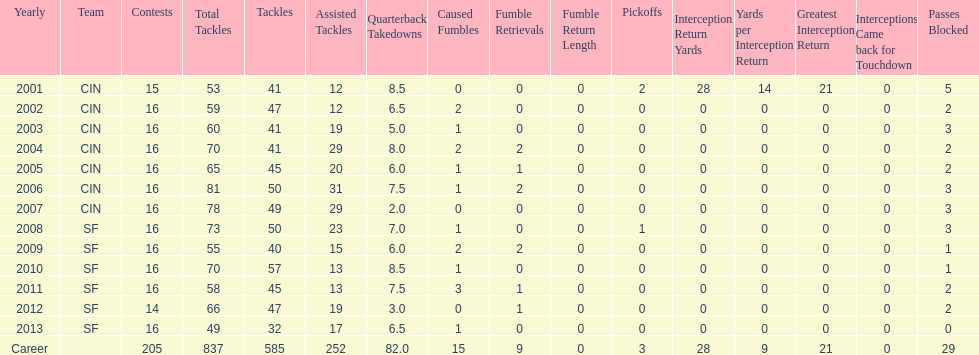How many seasons had combined tackles of 70 or more? 5. Write the full table. {'header': ['Yearly', 'Team', 'Contests', 'Total Tackles', 'Tackles', 'Assisted Tackles', 'Quarterback Takedowns', 'Caused Fumbles', 'Fumble Retrievals', 'Fumble Return Length', 'Pickoffs', 'Interception Return Yards', 'Yards per Interception Return', 'Greatest Interception Return', 'Interceptions Came back for Touchdown', 'Passes Blocked'], 'rows': [['2001', 'CIN', '15', '53', '41', '12', '8.5', '0', '0', '0', '2', '28', '14', '21', '0', '5'], ['2002', 'CIN', '16', '59', '47', '12', '6.5', '2', '0', '0', '0', '0', '0', '0', '0', '2'], ['2003', 'CIN', '16', '60', '41', '19', '5.0', '1', '0', '0', '0', '0', '0', '0', '0', '3'], ['2004', 'CIN', '16', '70', '41', '29', '8.0', '2', '2', '0', '0', '0', '0', '0', '0', '2'], ['2005', 'CIN', '16', '65', '45', '20', '6.0', '1', '1', '0', '0', '0', '0', '0', '0', '2'], ['2006', 'CIN', '16', '81', '50', '31', '7.5', '1', '2', '0', '0', '0', '0', '0', '0', '3'], ['2007', 'CIN', '16', '78', '49', '29', '2.0', '0', '0', '0', '0', '0', '0', '0', '0', '3'], ['2008', 'SF', '16', '73', '50', '23', '7.0', '1', '0', '0', '1', '0', '0', '0', '0', '3'], ['2009', 'SF', '16', '55', '40', '15', '6.0', '2', '2', '0', '0', '0', '0', '0', '0', '1'], ['2010', 'SF', '16', '70', '57', '13', '8.5', '1', '0', '0', '0', '0', '0', '0', '0', '1'], ['2011', 'SF', '16', '58', '45', '13', '7.5', '3', '1', '0', '0', '0', '0', '0', '0', '2'], ['2012', 'SF', '14', '66', '47', '19', '3.0', '0', '1', '0', '0', '0', '0', '0', '0', '2'], ['2013', 'SF', '16', '49', '32', '17', '6.5', '1', '0', '0', '0', '0', '0', '0', '0', '0'], ['Career', '', '205', '837', '585', '252', '82.0', '15', '9', '0', '3', '28', '9', '21', '0', '29']]} 